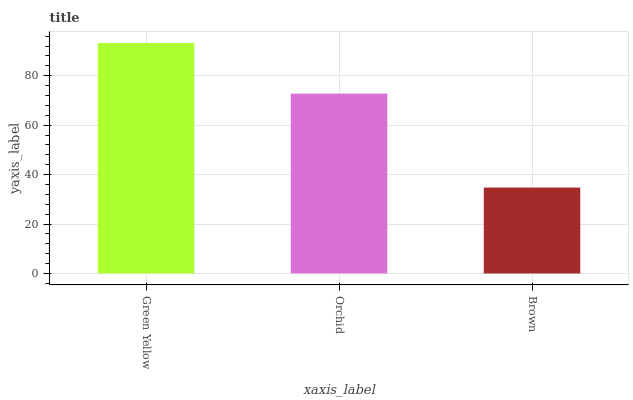Is Green Yellow the maximum?
Answer yes or no. Yes. Is Orchid the minimum?
Answer yes or no. No. Is Orchid the maximum?
Answer yes or no. No. Is Green Yellow greater than Orchid?
Answer yes or no. Yes. Is Orchid less than Green Yellow?
Answer yes or no. Yes. Is Orchid greater than Green Yellow?
Answer yes or no. No. Is Green Yellow less than Orchid?
Answer yes or no. No. Is Orchid the high median?
Answer yes or no. Yes. Is Orchid the low median?
Answer yes or no. Yes. Is Green Yellow the high median?
Answer yes or no. No. Is Brown the low median?
Answer yes or no. No. 